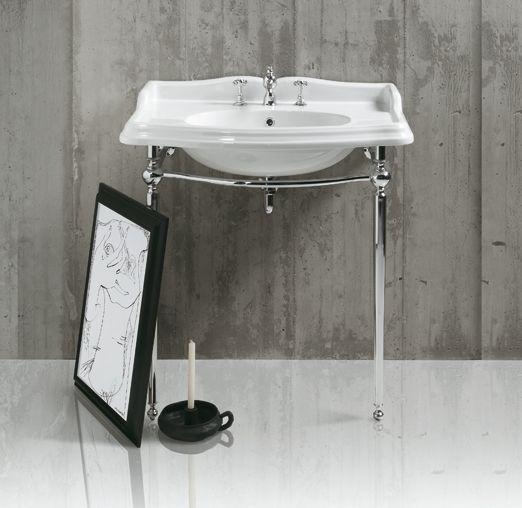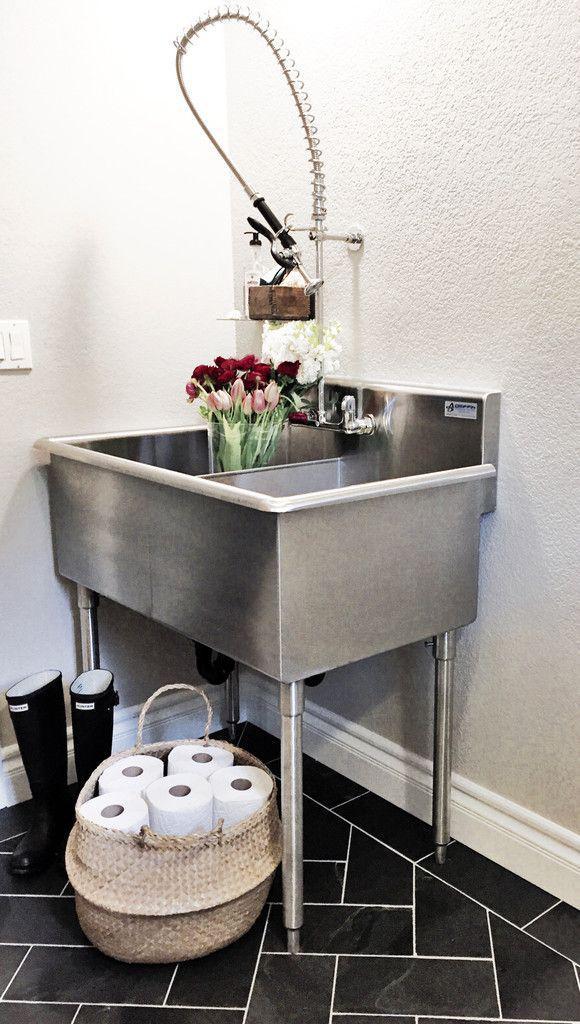The first image is the image on the left, the second image is the image on the right. Evaluate the accuracy of this statement regarding the images: "There is a silver colored sink, and a not-silver colored sink.". Is it true? Answer yes or no. Yes. The first image is the image on the left, the second image is the image on the right. Given the left and right images, does the statement "At least part of a round mirror is visible above a rectangular vanity." hold true? Answer yes or no. No. 